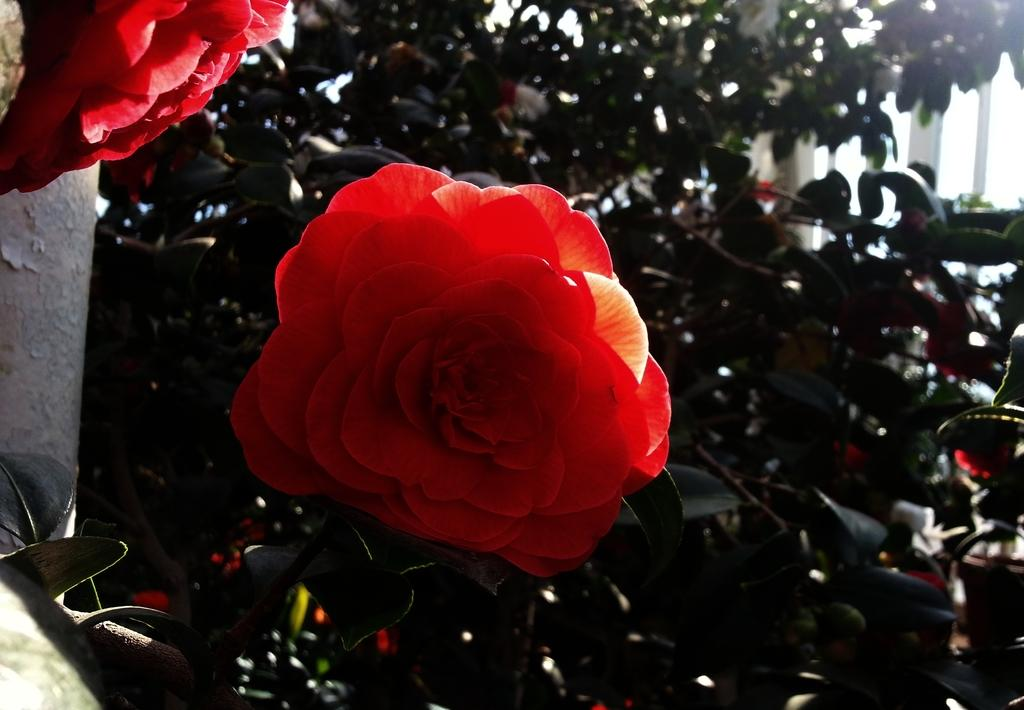What color are the flowers on the plant in the image? The flowers on the plant are red. Where is the plant located in the image? The plant is in a pot at the back. Can you describe any other features of the plant or its surroundings? There might be a glass door in the image. Can you see any ants crawling on the flowers in the image? There is no mention of ants in the image, so we cannot determine if they are present or not. How does the plant's breath affect the surrounding environment in the image? Plants do not have the ability to breathe like animals, so this question is not applicable to the image. 